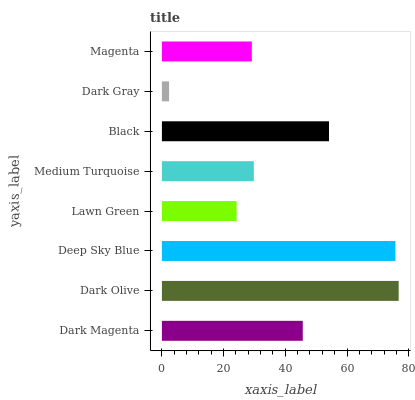Is Dark Gray the minimum?
Answer yes or no. Yes. Is Dark Olive the maximum?
Answer yes or no. Yes. Is Deep Sky Blue the minimum?
Answer yes or no. No. Is Deep Sky Blue the maximum?
Answer yes or no. No. Is Dark Olive greater than Deep Sky Blue?
Answer yes or no. Yes. Is Deep Sky Blue less than Dark Olive?
Answer yes or no. Yes. Is Deep Sky Blue greater than Dark Olive?
Answer yes or no. No. Is Dark Olive less than Deep Sky Blue?
Answer yes or no. No. Is Dark Magenta the high median?
Answer yes or no. Yes. Is Medium Turquoise the low median?
Answer yes or no. Yes. Is Dark Gray the high median?
Answer yes or no. No. Is Dark Magenta the low median?
Answer yes or no. No. 